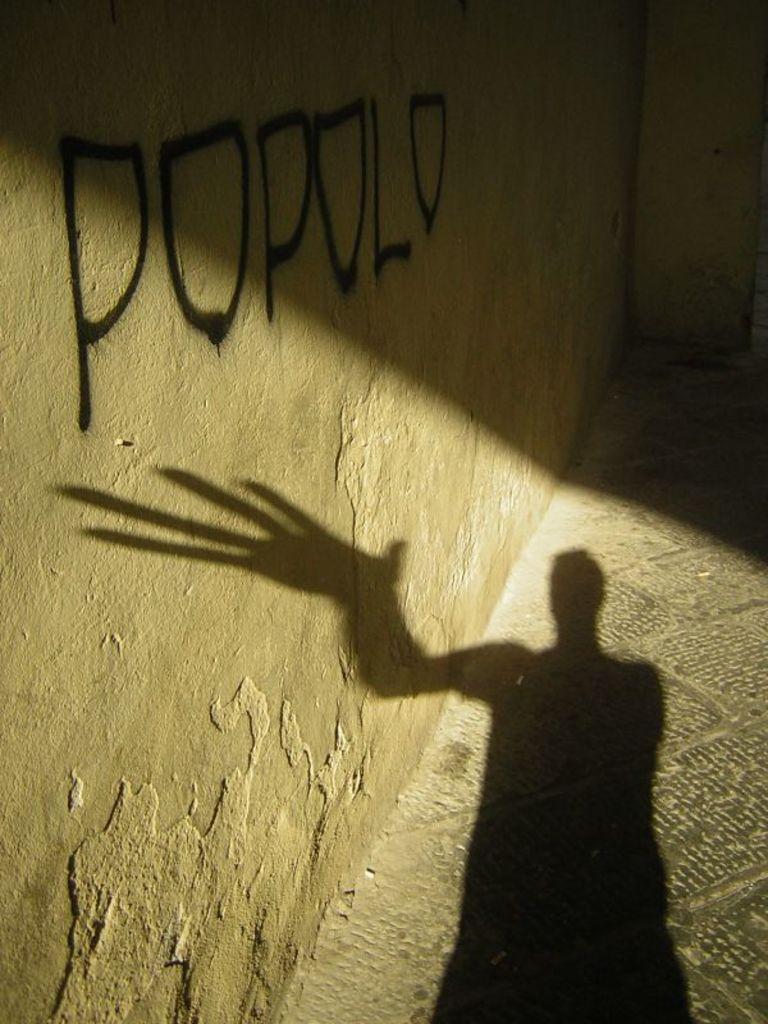In one or two sentences, can you explain what this image depicts? In this picture we can see a shadow of a person on the floor and on the left side of the floor there is a wall. 